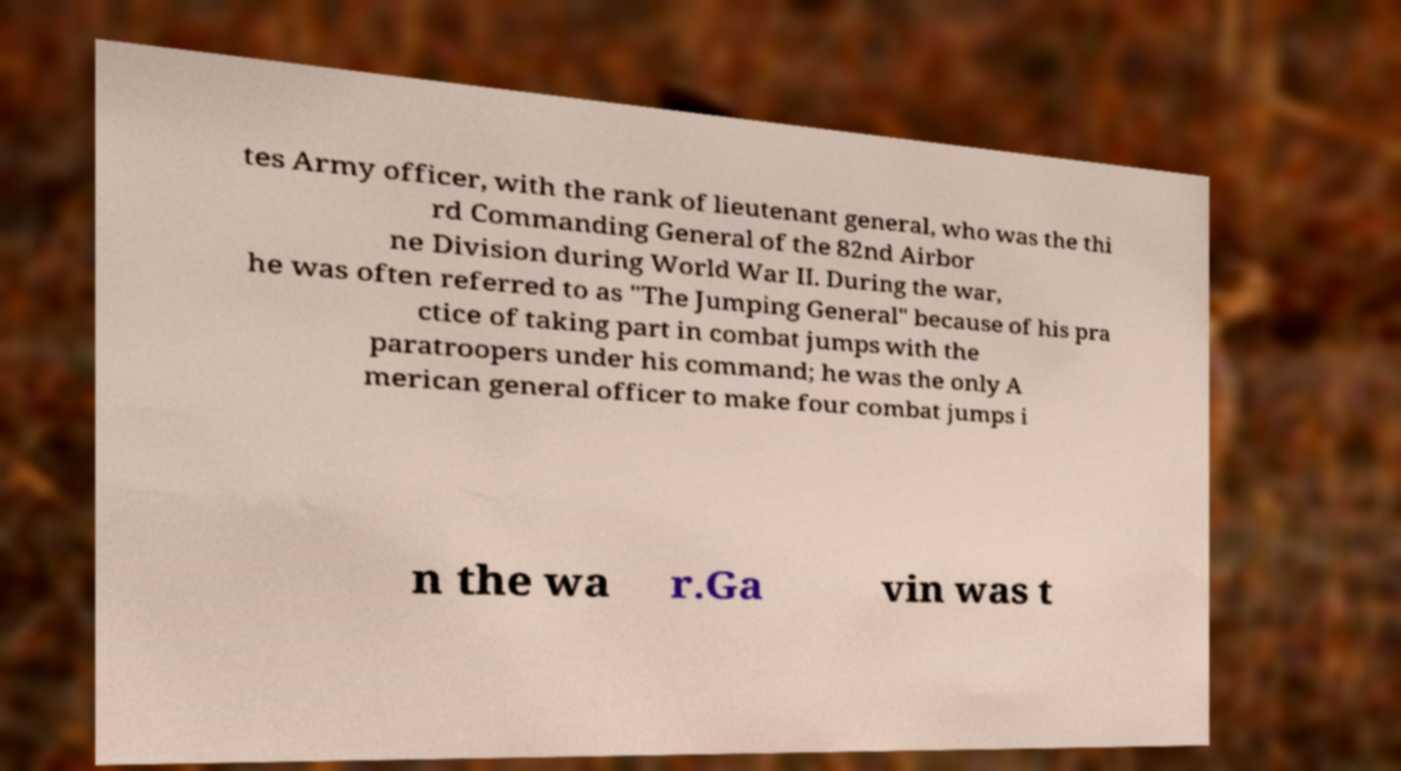There's text embedded in this image that I need extracted. Can you transcribe it verbatim? tes Army officer, with the rank of lieutenant general, who was the thi rd Commanding General of the 82nd Airbor ne Division during World War II. During the war, he was often referred to as "The Jumping General" because of his pra ctice of taking part in combat jumps with the paratroopers under his command; he was the only A merican general officer to make four combat jumps i n the wa r.Ga vin was t 